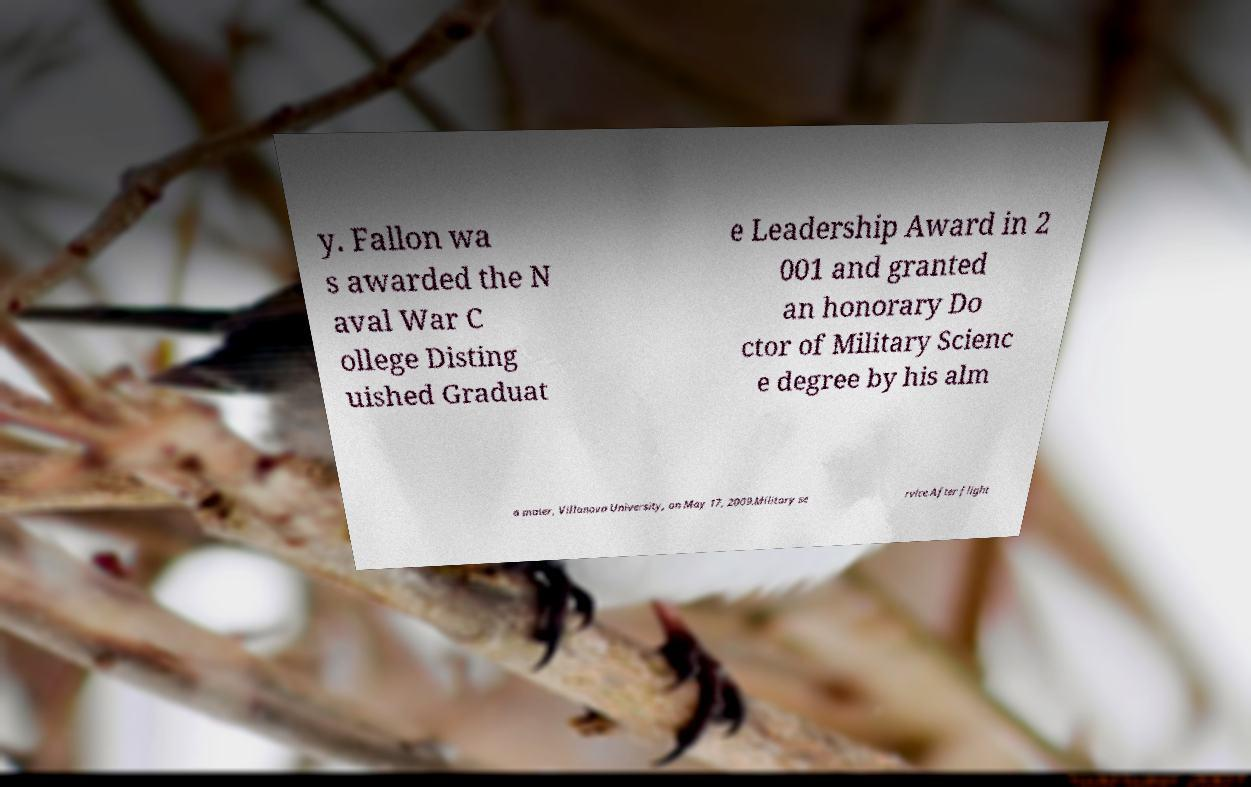I need the written content from this picture converted into text. Can you do that? y. Fallon wa s awarded the N aval War C ollege Disting uished Graduat e Leadership Award in 2 001 and granted an honorary Do ctor of Military Scienc e degree by his alm a mater, Villanova University, on May 17, 2009.Military se rvice.After flight 